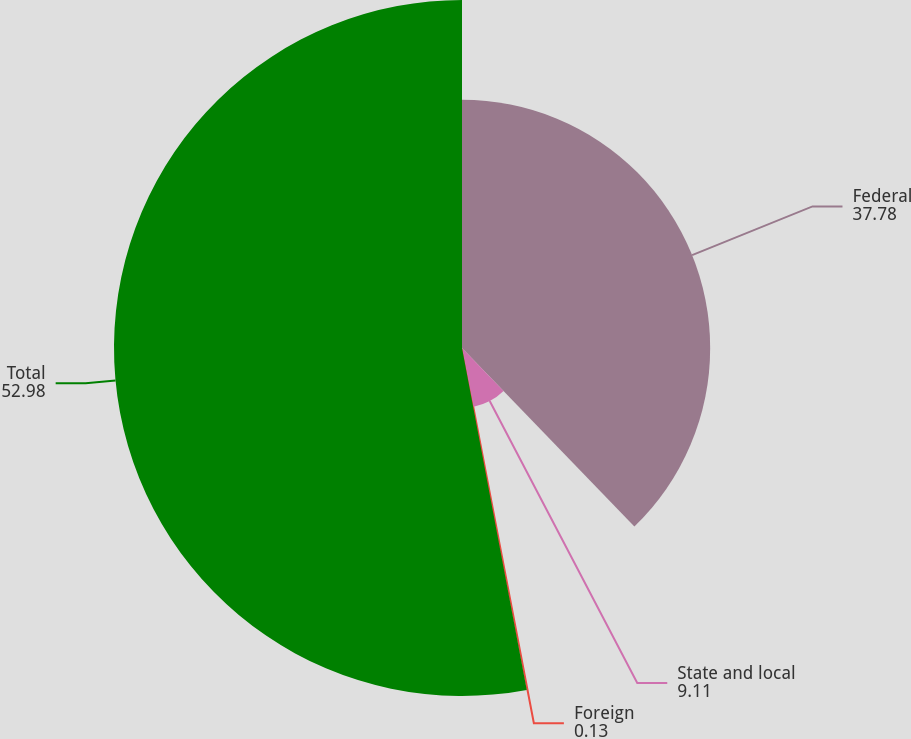Convert chart to OTSL. <chart><loc_0><loc_0><loc_500><loc_500><pie_chart><fcel>Federal<fcel>State and local<fcel>Foreign<fcel>Total<nl><fcel>37.78%<fcel>9.11%<fcel>0.13%<fcel>52.98%<nl></chart> 